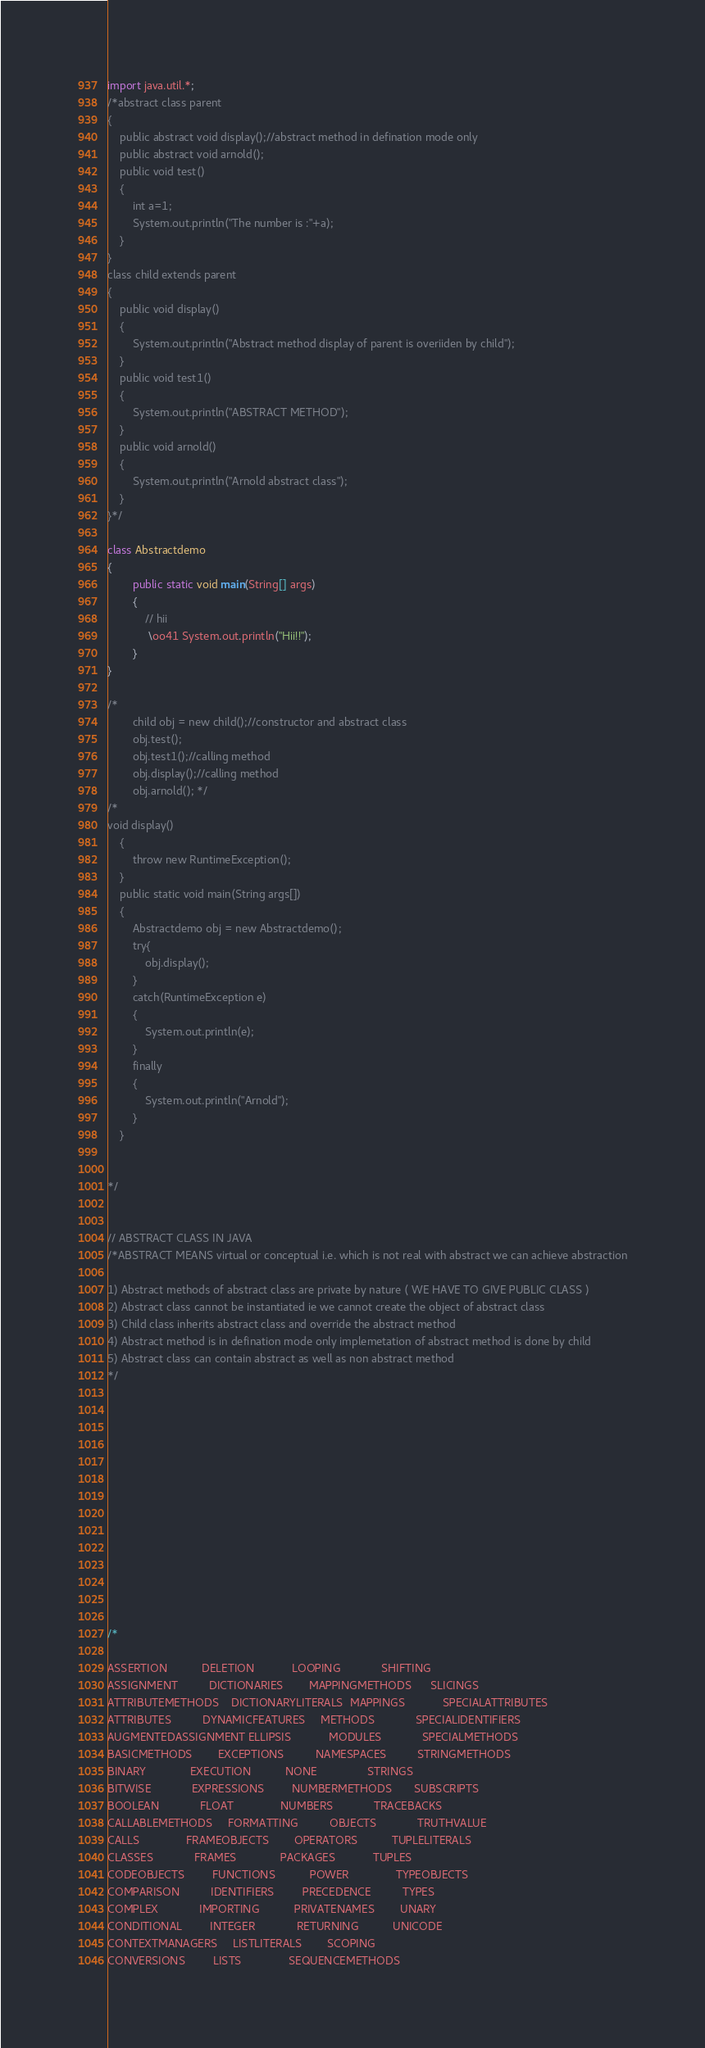Convert code to text. <code><loc_0><loc_0><loc_500><loc_500><_Java_>import java.util.*;
/*abstract class parent
{
	public abstract void display();//abstract method in defination mode only
	public abstract void arnold();
	public void test()
	{
		int a=1;
		System.out.println("The number is :"+a);
	}
}
class child extends parent 
{
	public void display()
	{
		System.out.println("Abstract method display of parent is overiiden by child");
	}
	public void test1()
	{
		System.out.println("ABSTRACT METHOD");
	}
	public void arnold()
	{
		System.out.println("Arnold abstract class");
	}	
}*/

class Abstractdemo
{
		public static void main(String[] args)
		{
			// hii
			 \oo41 System.out.println("Hii!!");		
		}
}

/*
		child obj = new child();//constructor and abstract class
		obj.test();
		obj.test1();//calling method 
		obj.display();//calling method
		obj.arnold(); */
/*
void display()
	{
		throw new RuntimeException();
	}
	public static void main(String args[]) 
	{
		Abstractdemo obj = new Abstractdemo();
		try{
			obj.display();
		}	
		catch(RuntimeException e)
		{
			System.out.println(e);
		}
		finally
		{
			System.out.println("Arnold");
		}
	}


*/


// ABSTRACT CLASS IN JAVA 
/*ABSTRACT MEANS virtual or conceptual i.e. which is not real with abstract we can achieve abstraction

1) Abstract methods of abstract class are private by nature ( WE HAVE TO GIVE PUBLIC CLASS )
2) Abstract class cannot be instantiated ie we cannot create the object of abstract class
3) Child class inherits abstract class and override the abstract method
4) Abstract method is in defination mode only implemetation of abstract method is done by child
5) Abstract class can contain abstract as well as non abstract method 
*/














/*

ASSERTION           DELETION            LOOPING             SHIFTING
ASSIGNMENT          DICTIONARIES        MAPPINGMETHODS      SLICINGS
ATTRIBUTEMETHODS    DICTIONARYLITERALS  MAPPINGS            SPECIALATTRIBUTES
ATTRIBUTES          DYNAMICFEATURES     METHODS             SPECIALIDENTIFIERS
AUGMENTEDASSIGNMENT ELLIPSIS            MODULES             SPECIALMETHODS
BASICMETHODS        EXCEPTIONS          NAMESPACES          STRINGMETHODS
BINARY              EXECUTION           NONE                STRINGS
BITWISE             EXPRESSIONS         NUMBERMETHODS       SUBSCRIPTS
BOOLEAN             FLOAT               NUMBERS             TRACEBACKS
CALLABLEMETHODS     FORMATTING          OBJECTS             TRUTHVALUE
CALLS               FRAMEOBJECTS        OPERATORS           TUPLELITERALS
CLASSES             FRAMES              PACKAGES            TUPLES
CODEOBJECTS         FUNCTIONS           POWER               TYPEOBJECTS
COMPARISON          IDENTIFIERS         PRECEDENCE          TYPES
COMPLEX             IMPORTING           PRIVATENAMES        UNARY
CONDITIONAL         INTEGER             RETURNING           UNICODE
CONTEXTMANAGERS     LISTLITERALS        SCOPING             
CONVERSIONS         LISTS               SEQUENCEMETHODS     </code> 